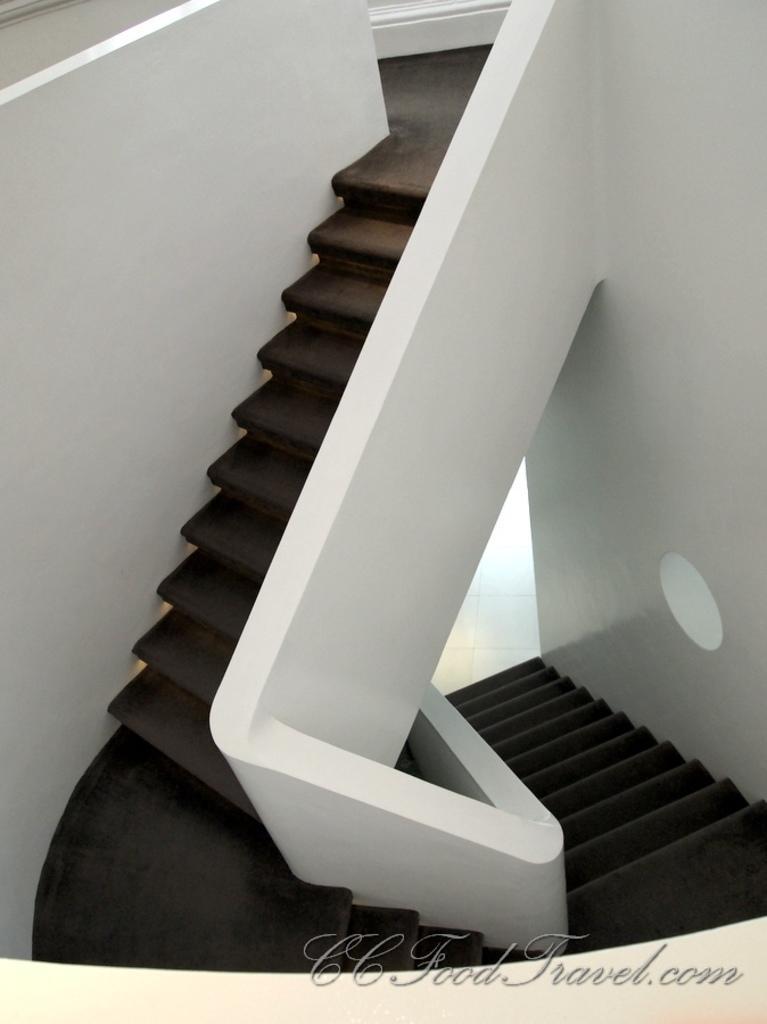How would you summarize this image in a sentence or two? In this image we can see a staircase. There is wall. At the bottom of the image there is text. 